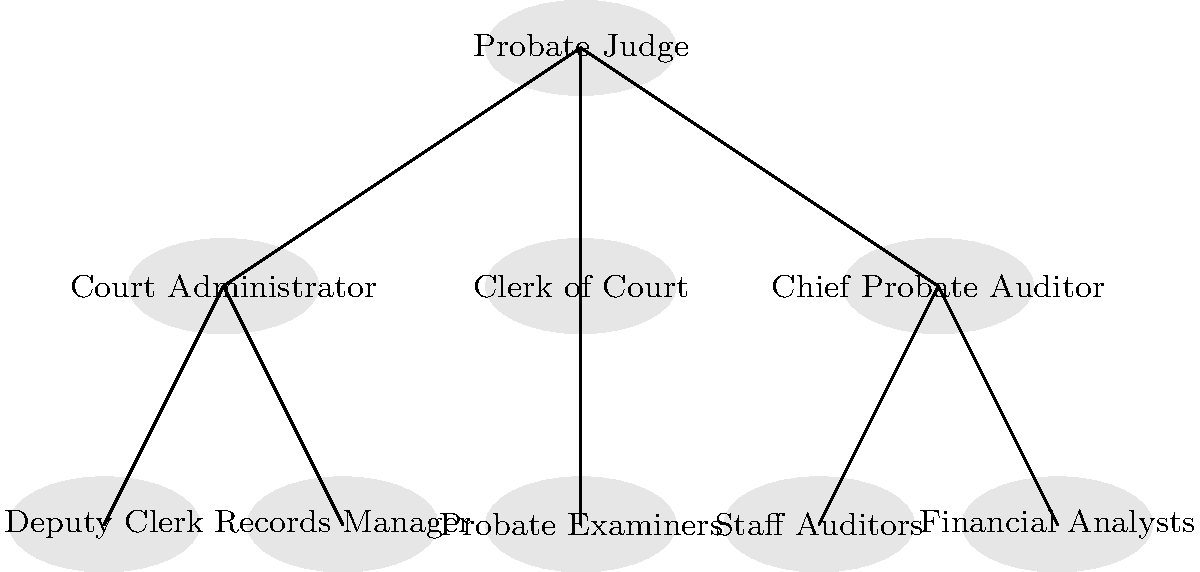In the probate court's organizational chart, which position directly oversees the Records Manager? To answer this question, let's analyze the organizational chart step-by-step:

1. The top of the chart shows the Probate Judge, who is the highest authority in the probate court.

2. Directly below the Probate Judge, we see three positions:
   a. Court Administrator
   b. Clerk of Court
   c. Chief Probate Auditor

3. The Records Manager is positioned below and connected to one of these three positions.

4. Following the lines, we can see that the Records Manager is directly connected to the Court Administrator.

5. This indicates that the Court Administrator is the immediate supervisor of the Records Manager in the probate court's organizational structure.

6. The other positions under the Court Administrator (Deputy Clerk) and under other branches are not relevant to answering this specific question.

Therefore, based on the organizational chart, the position that directly oversees the Records Manager is the Court Administrator.
Answer: Court Administrator 